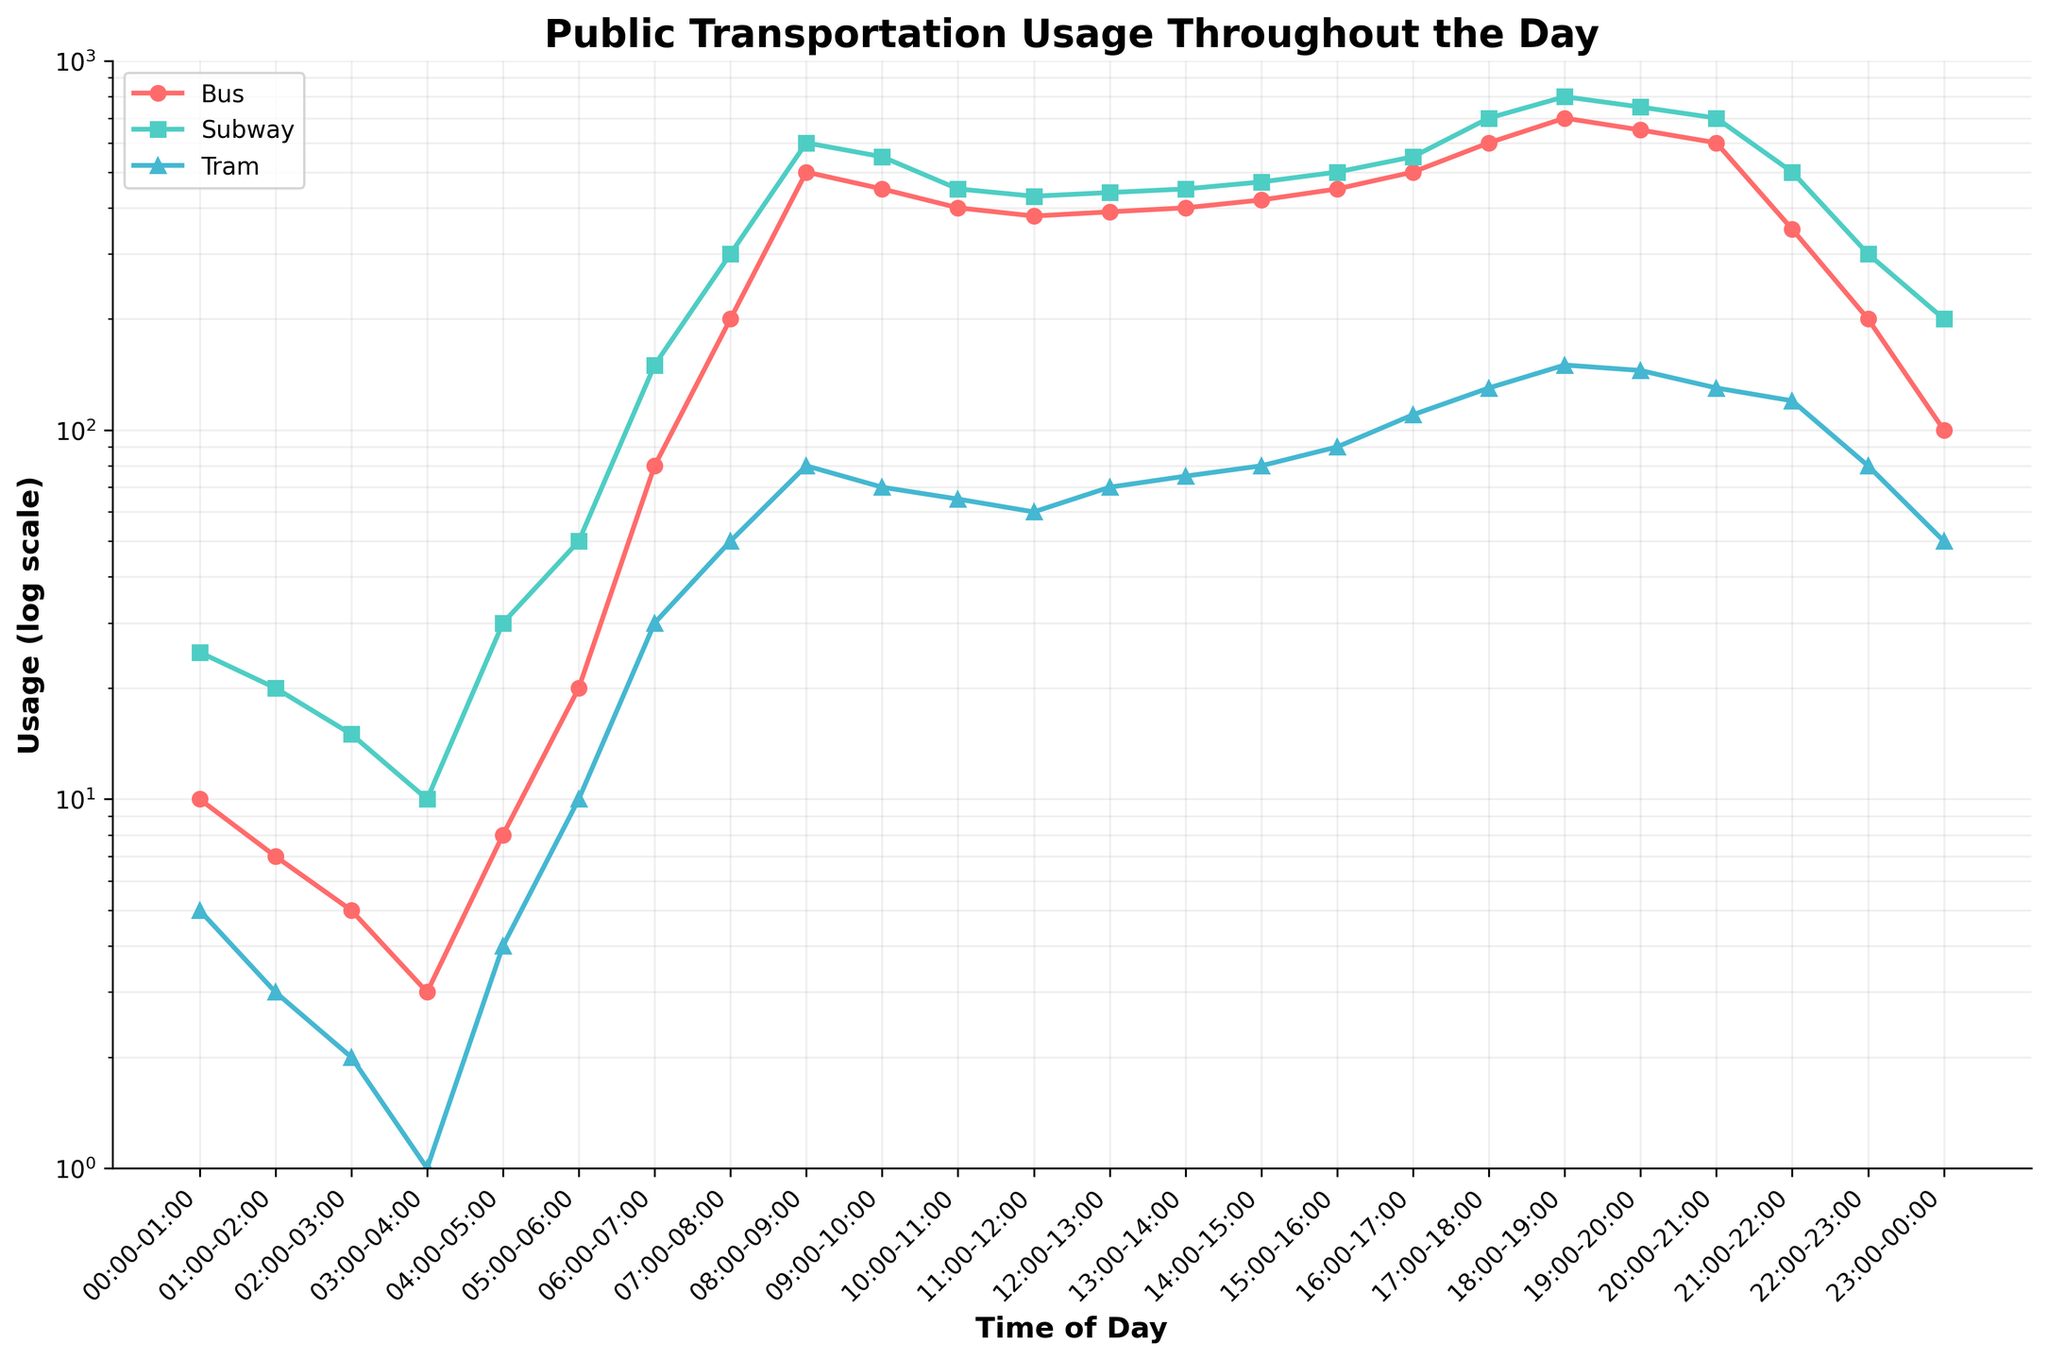What's the title of the figure? The title of the figure is displayed prominently at the top and summarizes the content of the plot.
Answer: Public Transportation Usage Throughout the Day What is the y-axis representing and how is it scaled? The y-axis represents 'Usage' and it is scaled using a logarithmic scale, ranging from 1 to 1000.
Answer: Usage (log scale) How does bus usage change from 00:00-01:00 to 07:00-08:00? To determine the change in bus usage, look at the specific values at these times. At 00:00-01:00, it's 10, and at 07:00-08:00, it's 200, showing an increase.
Answer: Increases At which time is subway usage at its peak, and what is the value? To find the peak subway usage, identify the highest point on the subway line. The highest value is at 19:00-20:00 where it peaks at 800.
Answer: 19:00-20:00, 800 What time slot has the lowest tram usage, and what is that value? The lowest tram usage can be found by identifying the lowest point on the tram usage line. The value is 1 at 03:00-04:00.
Answer: 03:00-04:00, 1 Which mode of transportation has the highest usage at 18:00-19:00? Compare the usage values of buses, subways, and trams at 18:00-19:00. Here, subway usage is highest at 800.
Answer: Subway What's the average usage of buses between 10:00-11:00 and 14:00-15:00? Find the bus usage at 10:00-11:00 and 14:00-15:00, then calculate the average: (400 + 420) / 2 = 410.
Answer: 410 How does tram usage change from 09:00-10:00 to 10:00-11:00? Look at the tram usage at 09:00-10:00 and 10:00-11:00, the values are 70 and 65 respectively, showing a decrease.
Answer: Decreases Which time slot shows a sharp increase in all three modes of transportation? Identify the time slot where all lines show a noticeable climb. Between 05:00-06:00 and 06:00-07:00, usage sharply increases for all three modes.
Answer: 05:00-06:00 to 06:00-07:00 What pattern can be observed in subway usage between 20:00-00:00? Examine the trend from 20:00 to 00:00. Subway usage consistently decreases from 700 at 20:00-21:00 to 200 at 23:00-00:00.
Answer: Decreasing pattern 